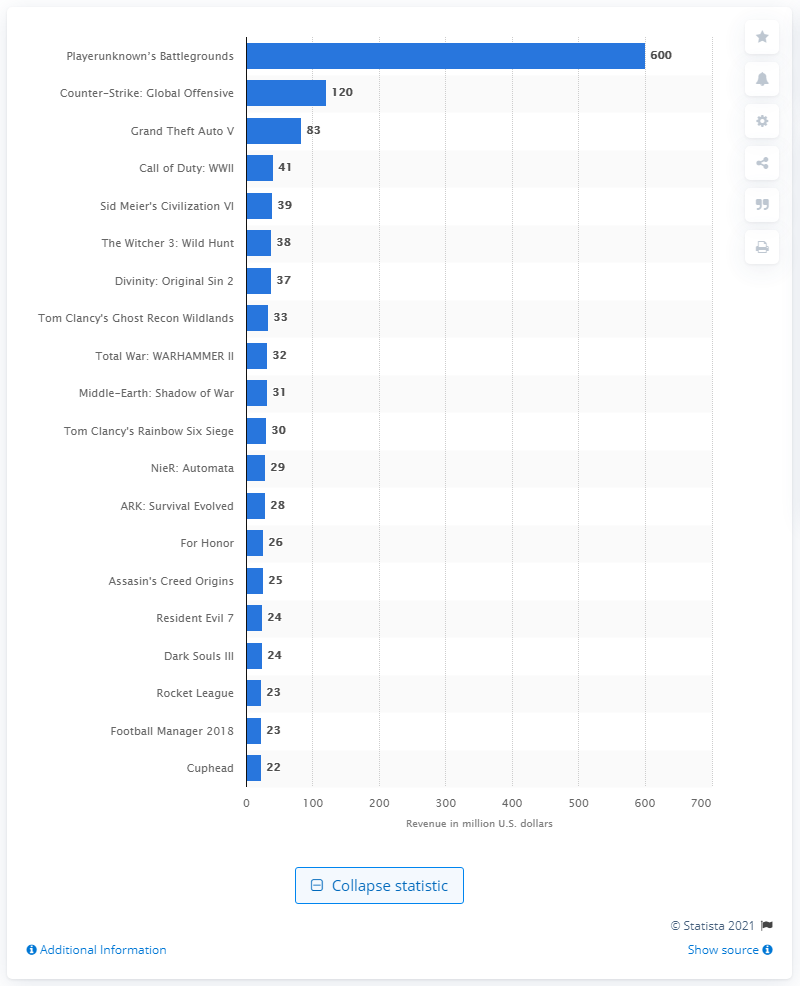Identify some key points in this picture. According to estimates in 2017, the estimated revenue of Grand Theft Auto V was approximately 83. PUBG generated $600 million in sales from Steam in 2017. 